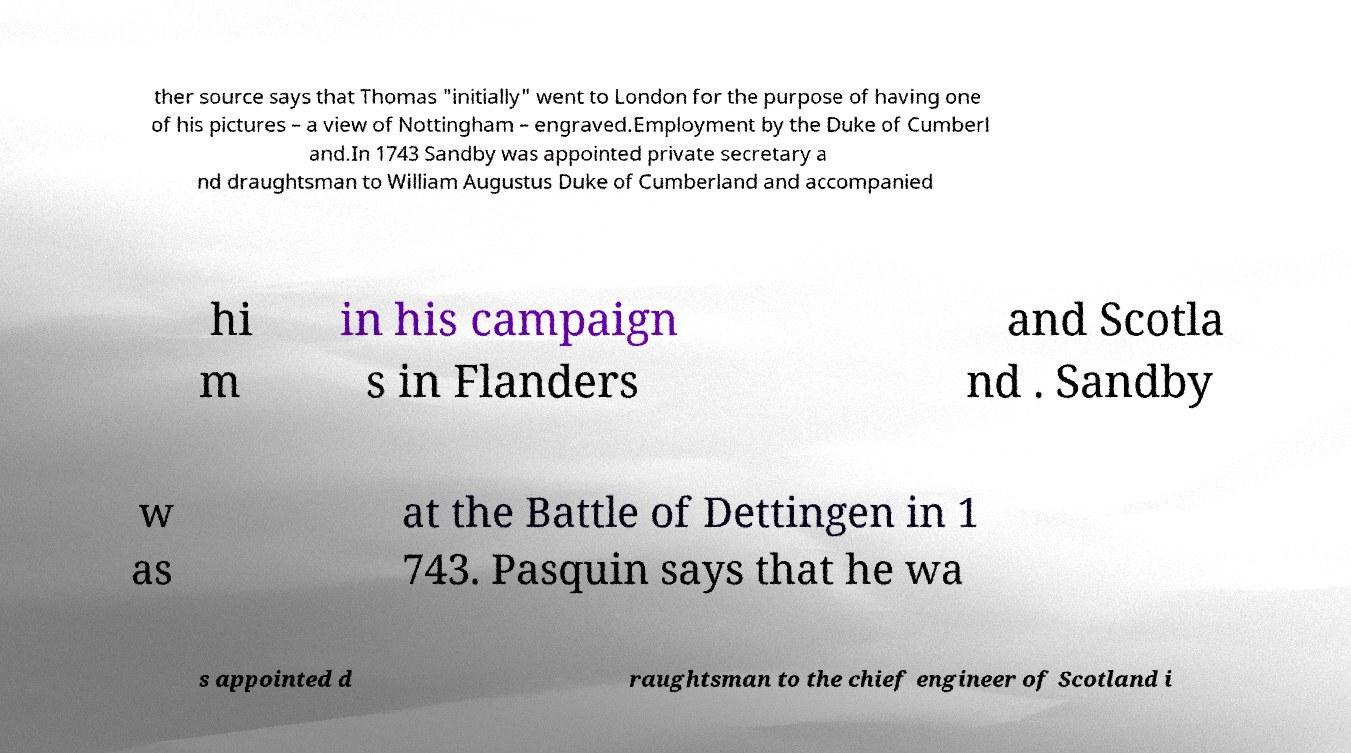Please read and relay the text visible in this image. What does it say? ther source says that Thomas "initially" went to London for the purpose of having one of his pictures – a view of Nottingham – engraved.Employment by the Duke of Cumberl and.In 1743 Sandby was appointed private secretary a nd draughtsman to William Augustus Duke of Cumberland and accompanied hi m in his campaign s in Flanders and Scotla nd . Sandby w as at the Battle of Dettingen in 1 743. Pasquin says that he wa s appointed d raughtsman to the chief engineer of Scotland i 